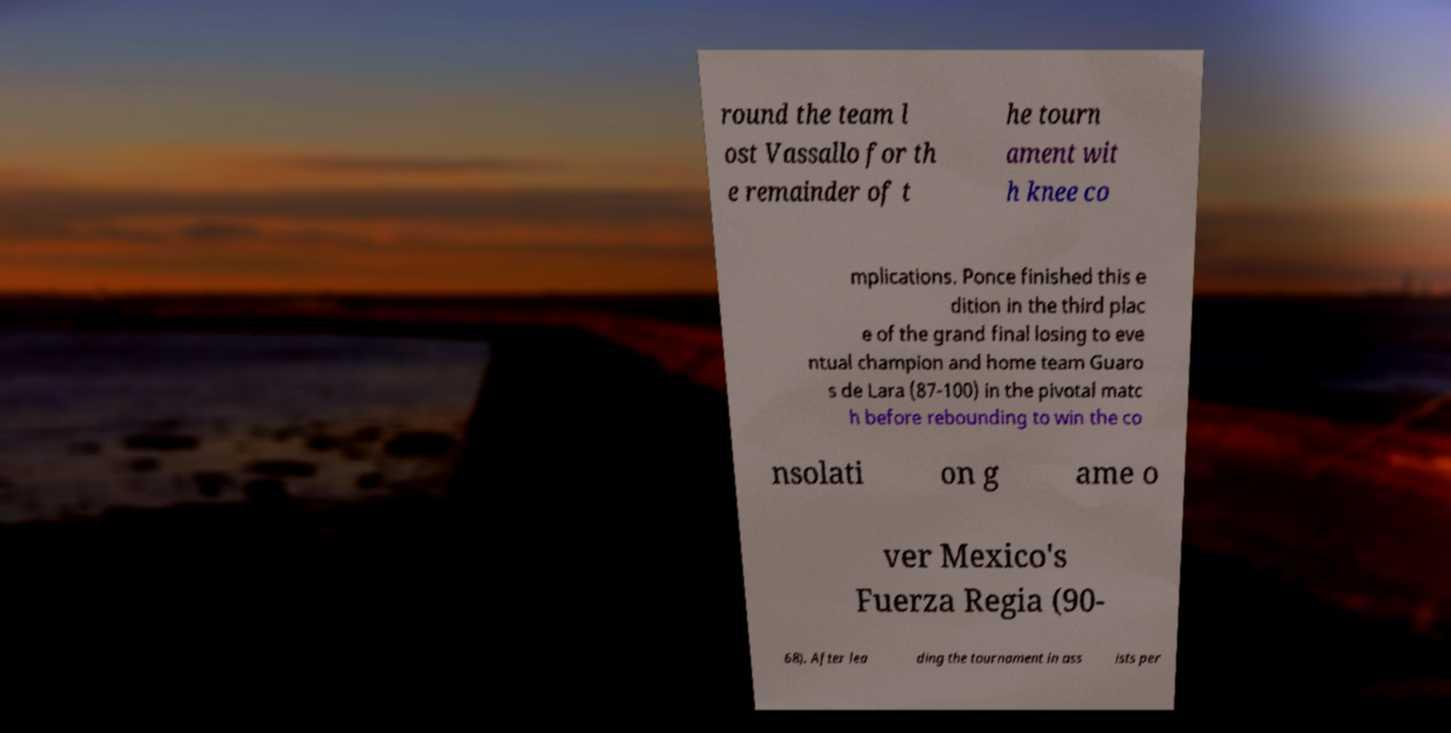I need the written content from this picture converted into text. Can you do that? round the team l ost Vassallo for th e remainder of t he tourn ament wit h knee co mplications. Ponce finished this e dition in the third plac e of the grand final losing to eve ntual champion and home team Guaro s de Lara (87-100) in the pivotal matc h before rebounding to win the co nsolati on g ame o ver Mexico's Fuerza Regia (90- 68). After lea ding the tournament in ass ists per 